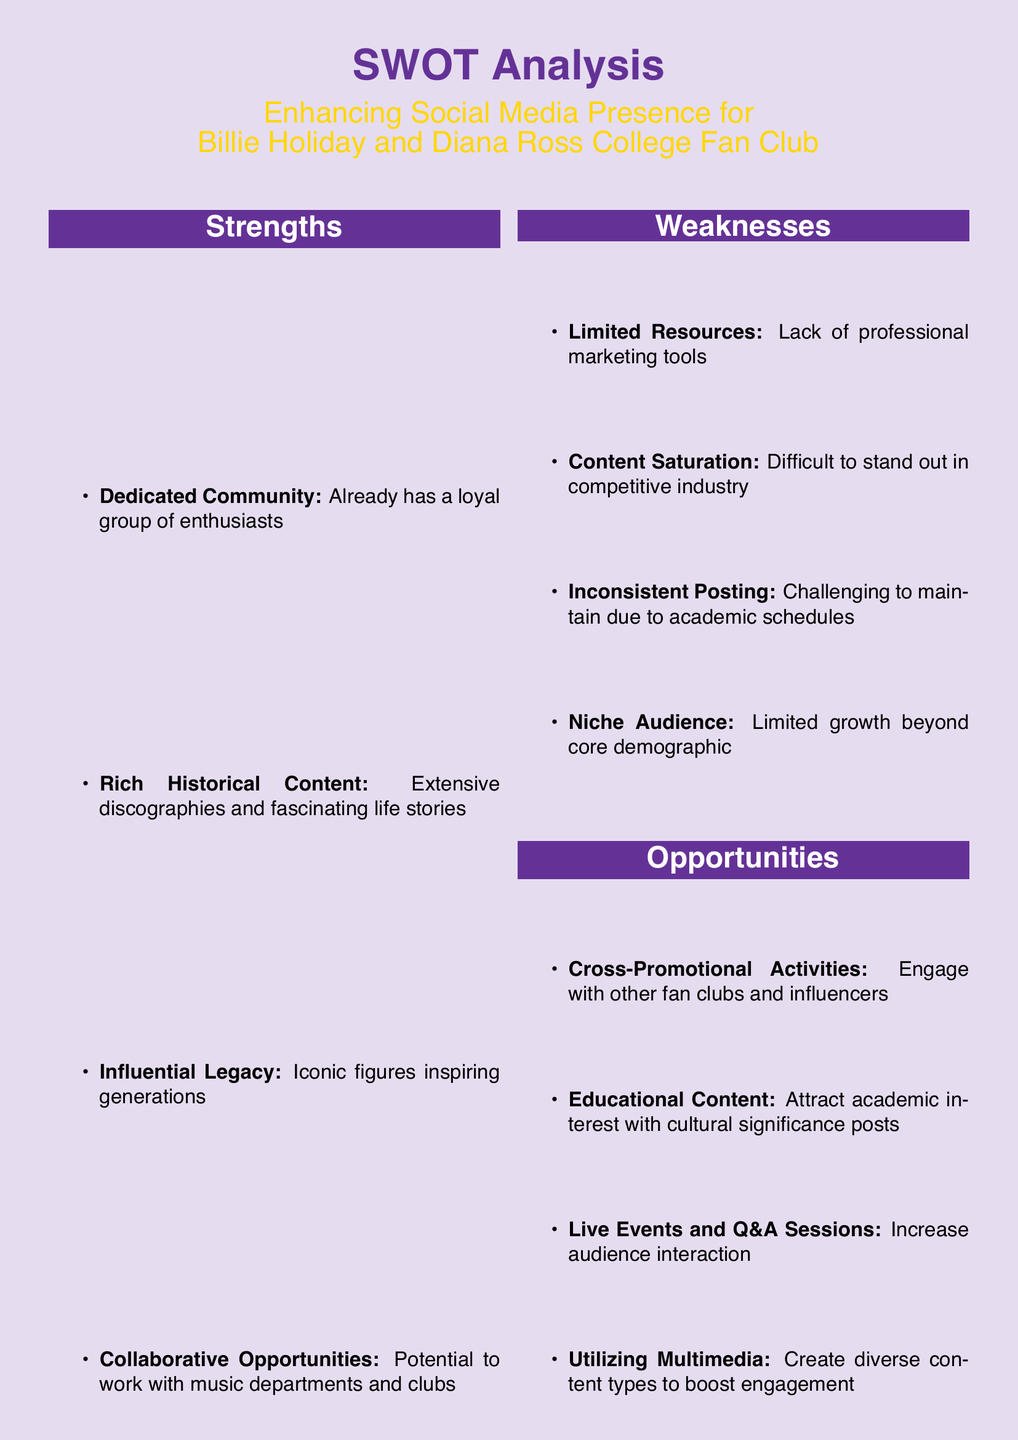What is one strength mentioned in the analysis? The strength section outlines various advantages, including the presence of a dedicated community.
Answer: Dedicated Community What is a weakness of the fan club? The weaknesses detail challenges faced, one being the limited resources available to the club.
Answer: Limited Resources Name one opportunity for enhancing social media presence. The opportunities suggest various strategies, such as engaging in cross-promotional activities with others.
Answer: Cross-Promotional Activities How many threats are listed in the analysis? The threats section contains a total of four different threats identified.
Answer: 4 What kind of content could attract academic interest? The opportunities section points out that educational content could be a key focus to attract interest.
Answer: Educational Content What color is used as the background in the document? The background color is specified as light purple in the document’s design.
Answer: Light Purple Which iconic figure is mentioned alongside Billie Holiday? The analysis specifically mentions another influential figure, Diana Ross, in relation to the fan club.
Answer: Diana Ross How many sections are included in the SWOT analysis? The document consists of four distinct sections labeled strengths, weaknesses, opportunities, and threats.
Answer: 4 